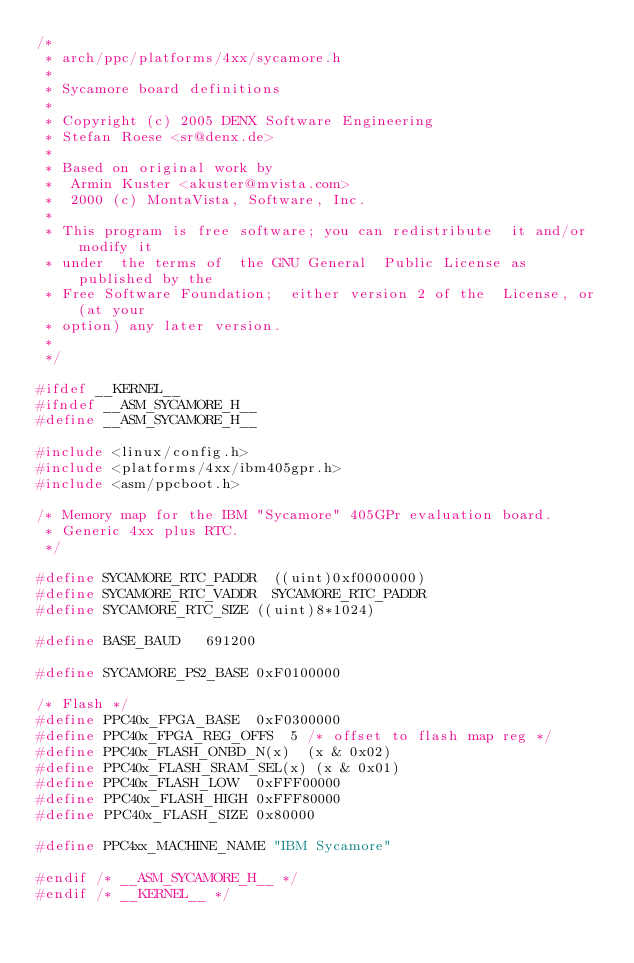<code> <loc_0><loc_0><loc_500><loc_500><_C_>/*
 * arch/ppc/platforms/4xx/sycamore.h
 *
 * Sycamore board definitions
 *
 * Copyright (c) 2005 DENX Software Engineering
 * Stefan Roese <sr@denx.de>
 *
 * Based on original work by
 * 	Armin Kuster <akuster@mvista.com>
 *	2000 (c) MontaVista, Software, Inc.
 *
 * This program is free software; you can redistribute  it and/or modify it
 * under  the terms of  the GNU General  Public License as published by the
 * Free Software Foundation;  either version 2 of the  License, or (at your
 * option) any later version.
 *
 */

#ifdef __KERNEL__
#ifndef __ASM_SYCAMORE_H__
#define __ASM_SYCAMORE_H__

#include <linux/config.h>
#include <platforms/4xx/ibm405gpr.h>
#include <asm/ppcboot.h>

/* Memory map for the IBM "Sycamore" 405GPr evaluation board.
 * Generic 4xx plus RTC.
 */

#define SYCAMORE_RTC_PADDR	((uint)0xf0000000)
#define SYCAMORE_RTC_VADDR	SYCAMORE_RTC_PADDR
#define SYCAMORE_RTC_SIZE	((uint)8*1024)

#define BASE_BAUD		691200

#define SYCAMORE_PS2_BASE	0xF0100000

/* Flash */
#define PPC40x_FPGA_BASE	0xF0300000
#define PPC40x_FPGA_REG_OFFS	5	/* offset to flash map reg */
#define PPC40x_FLASH_ONBD_N(x)	(x & 0x02)
#define PPC40x_FLASH_SRAM_SEL(x) (x & 0x01)
#define PPC40x_FLASH_LOW	0xFFF00000
#define PPC40x_FLASH_HIGH	0xFFF80000
#define PPC40x_FLASH_SIZE	0x80000

#define PPC4xx_MACHINE_NAME	"IBM Sycamore"

#endif /* __ASM_SYCAMORE_H__ */
#endif /* __KERNEL__ */
</code> 